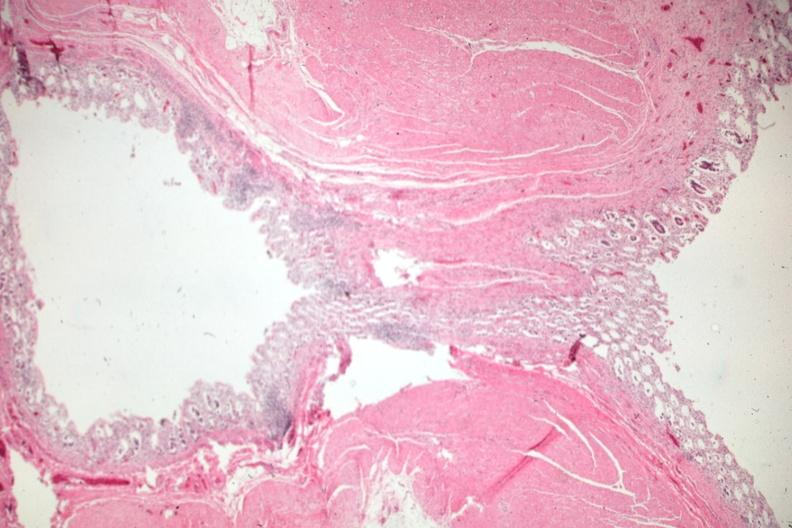s gastrointestinal present?
Answer the question using a single word or phrase. Yes 